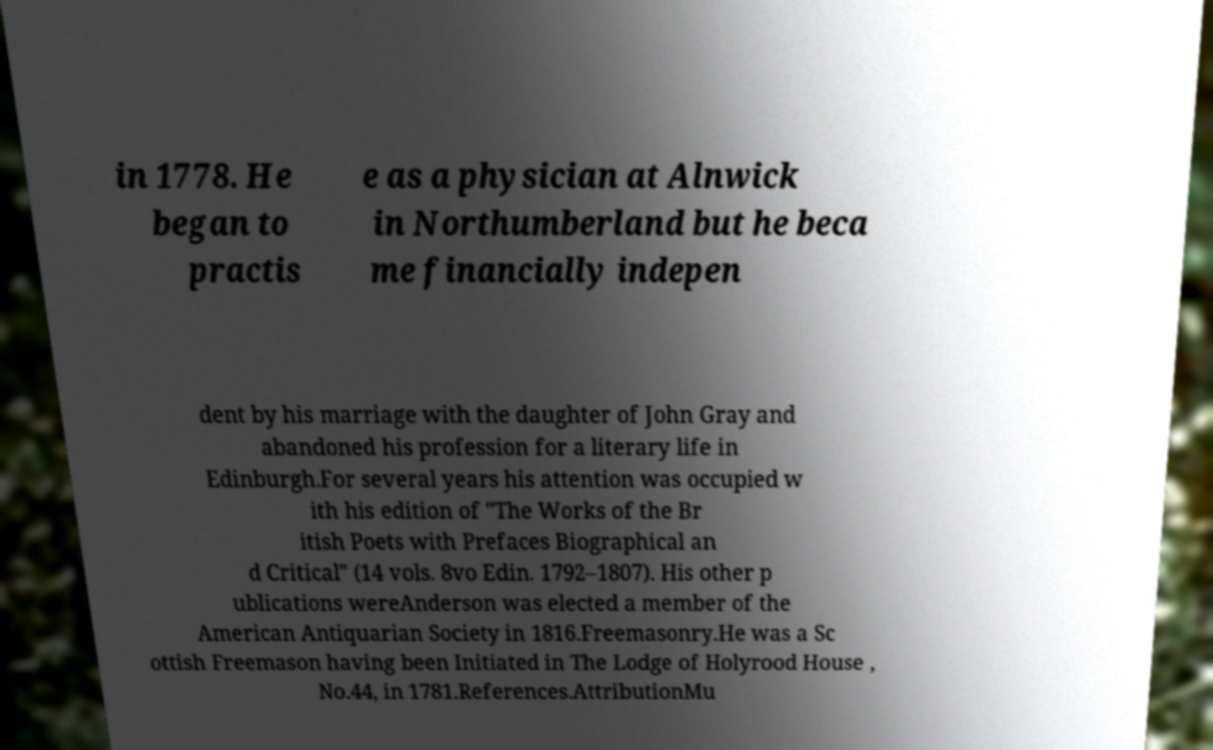Please identify and transcribe the text found in this image. in 1778. He began to practis e as a physician at Alnwick in Northumberland but he beca me financially indepen dent by his marriage with the daughter of John Gray and abandoned his profession for a literary life in Edinburgh.For several years his attention was occupied w ith his edition of "The Works of the Br itish Poets with Prefaces Biographical an d Critical" (14 vols. 8vo Edin. 1792–1807). His other p ublications wereAnderson was elected a member of the American Antiquarian Society in 1816.Freemasonry.He was a Sc ottish Freemason having been Initiated in The Lodge of Holyrood House , No.44, in 1781.References.AttributionMu 